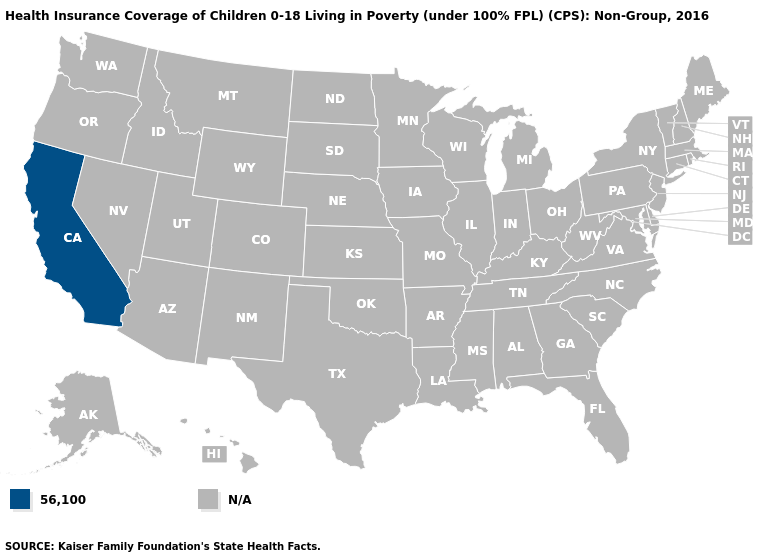Does the first symbol in the legend represent the smallest category?
Give a very brief answer. Yes. Name the states that have a value in the range N/A?
Short answer required. Alabama, Alaska, Arizona, Arkansas, Colorado, Connecticut, Delaware, Florida, Georgia, Hawaii, Idaho, Illinois, Indiana, Iowa, Kansas, Kentucky, Louisiana, Maine, Maryland, Massachusetts, Michigan, Minnesota, Mississippi, Missouri, Montana, Nebraska, Nevada, New Hampshire, New Jersey, New Mexico, New York, North Carolina, North Dakota, Ohio, Oklahoma, Oregon, Pennsylvania, Rhode Island, South Carolina, South Dakota, Tennessee, Texas, Utah, Vermont, Virginia, Washington, West Virginia, Wisconsin, Wyoming. Name the states that have a value in the range 56,100?
Keep it brief. California. What is the lowest value in the USA?
Write a very short answer. 56,100. What is the value of Michigan?
Concise answer only. N/A. What is the value of Nebraska?
Be succinct. N/A. Which states have the lowest value in the West?
Write a very short answer. California. What is the value of Montana?
Short answer required. N/A. Is the legend a continuous bar?
Keep it brief. No. How many symbols are there in the legend?
Write a very short answer. 2. What is the lowest value in states that border Arizona?
Keep it brief. 56,100. 